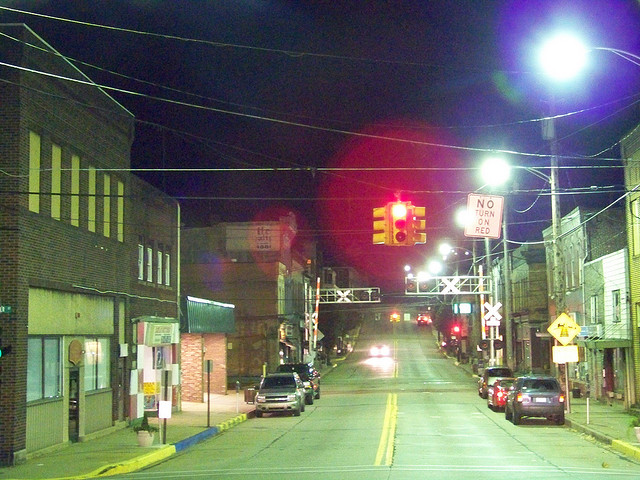Please transcribe the text in this image. NO TURN ON RED 